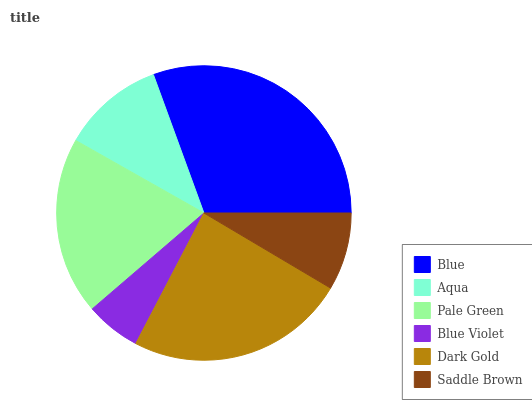Is Blue Violet the minimum?
Answer yes or no. Yes. Is Blue the maximum?
Answer yes or no. Yes. Is Aqua the minimum?
Answer yes or no. No. Is Aqua the maximum?
Answer yes or no. No. Is Blue greater than Aqua?
Answer yes or no. Yes. Is Aqua less than Blue?
Answer yes or no. Yes. Is Aqua greater than Blue?
Answer yes or no. No. Is Blue less than Aqua?
Answer yes or no. No. Is Pale Green the high median?
Answer yes or no. Yes. Is Aqua the low median?
Answer yes or no. Yes. Is Dark Gold the high median?
Answer yes or no. No. Is Saddle Brown the low median?
Answer yes or no. No. 